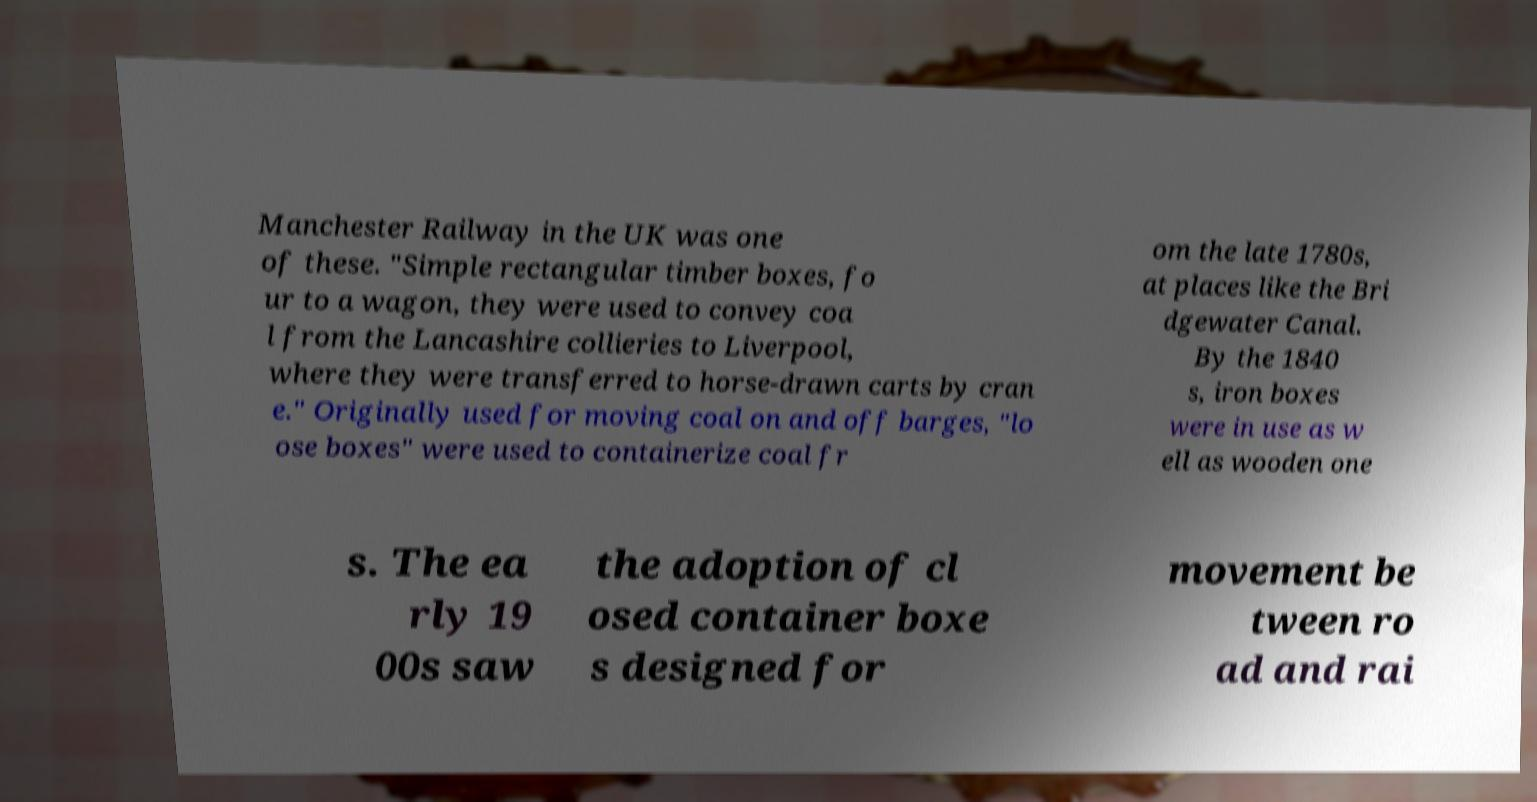For documentation purposes, I need the text within this image transcribed. Could you provide that? Manchester Railway in the UK was one of these. "Simple rectangular timber boxes, fo ur to a wagon, they were used to convey coa l from the Lancashire collieries to Liverpool, where they were transferred to horse-drawn carts by cran e." Originally used for moving coal on and off barges, "lo ose boxes" were used to containerize coal fr om the late 1780s, at places like the Bri dgewater Canal. By the 1840 s, iron boxes were in use as w ell as wooden one s. The ea rly 19 00s saw the adoption of cl osed container boxe s designed for movement be tween ro ad and rai 